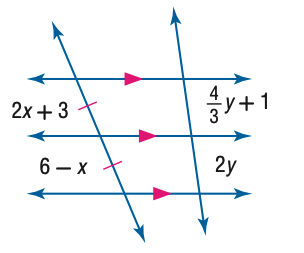Answer the mathemtical geometry problem and directly provide the correct option letter.
Question: Find y.
Choices: A: 1.0 B: 1.5 C: 2.0 D: 2.5 B 